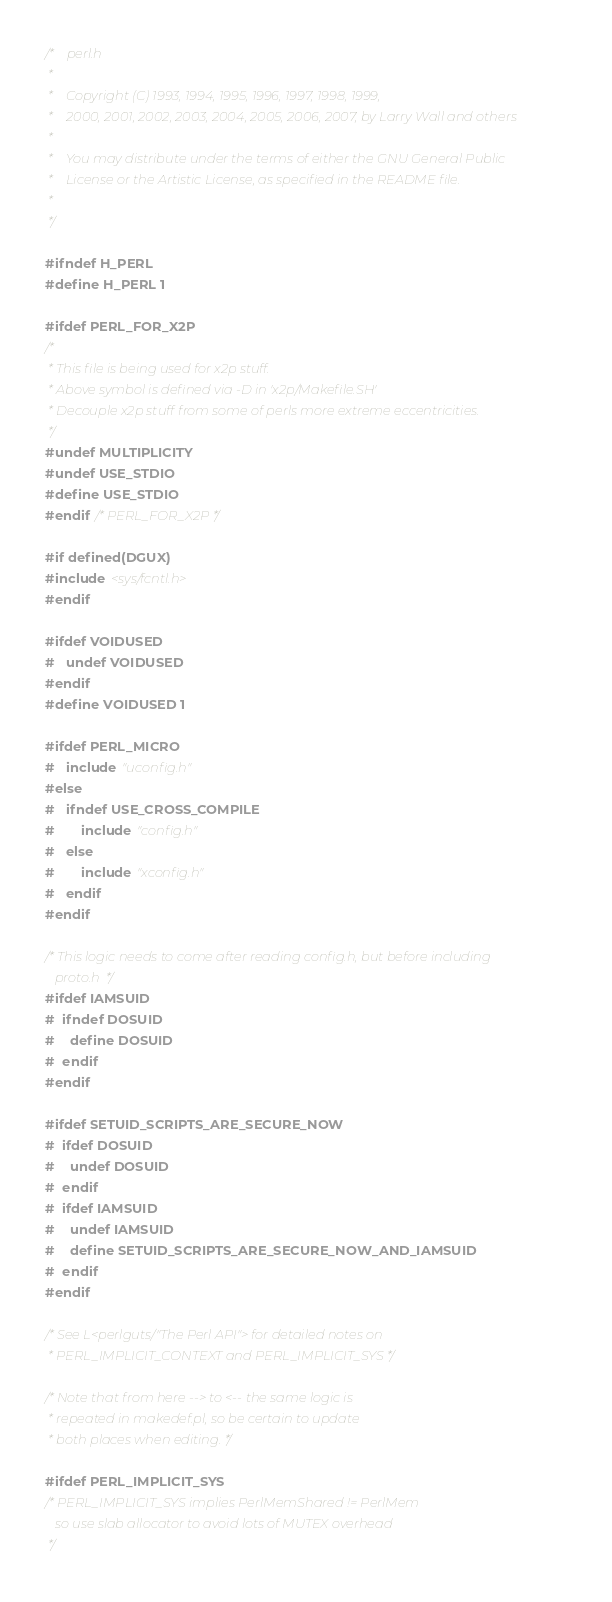<code> <loc_0><loc_0><loc_500><loc_500><_C_>/*    perl.h
 *
 *    Copyright (C) 1993, 1994, 1995, 1996, 1997, 1998, 1999,
 *    2000, 2001, 2002, 2003, 2004, 2005, 2006, 2007, by Larry Wall and others
 *
 *    You may distribute under the terms of either the GNU General Public
 *    License or the Artistic License, as specified in the README file.
 *
 */

#ifndef H_PERL
#define H_PERL 1

#ifdef PERL_FOR_X2P
/*
 * This file is being used for x2p stuff.
 * Above symbol is defined via -D in 'x2p/Makefile.SH'
 * Decouple x2p stuff from some of perls more extreme eccentricities.
 */
#undef MULTIPLICITY
#undef USE_STDIO
#define USE_STDIO
#endif /* PERL_FOR_X2P */

#if defined(DGUX)
#include <sys/fcntl.h>
#endif

#ifdef VOIDUSED
#   undef VOIDUSED
#endif 
#define VOIDUSED 1

#ifdef PERL_MICRO
#   include "uconfig.h"
#else
#   ifndef USE_CROSS_COMPILE
#       include "config.h"
#   else
#       include "xconfig.h"
#   endif
#endif

/* This logic needs to come after reading config.h, but before including
   proto.h  */
#ifdef IAMSUID
#  ifndef DOSUID
#    define DOSUID
#  endif
#endif

#ifdef SETUID_SCRIPTS_ARE_SECURE_NOW
#  ifdef DOSUID
#    undef DOSUID
#  endif
#  ifdef IAMSUID
#    undef IAMSUID
#    define SETUID_SCRIPTS_ARE_SECURE_NOW_AND_IAMSUID
#  endif
#endif

/* See L<perlguts/"The Perl API"> for detailed notes on
 * PERL_IMPLICIT_CONTEXT and PERL_IMPLICIT_SYS */

/* Note that from here --> to <-- the same logic is
 * repeated in makedef.pl, so be certain to update
 * both places when editing. */

#ifdef PERL_IMPLICIT_SYS
/* PERL_IMPLICIT_SYS implies PerlMemShared != PerlMem
   so use slab allocator to avoid lots of MUTEX overhead
 */</code> 